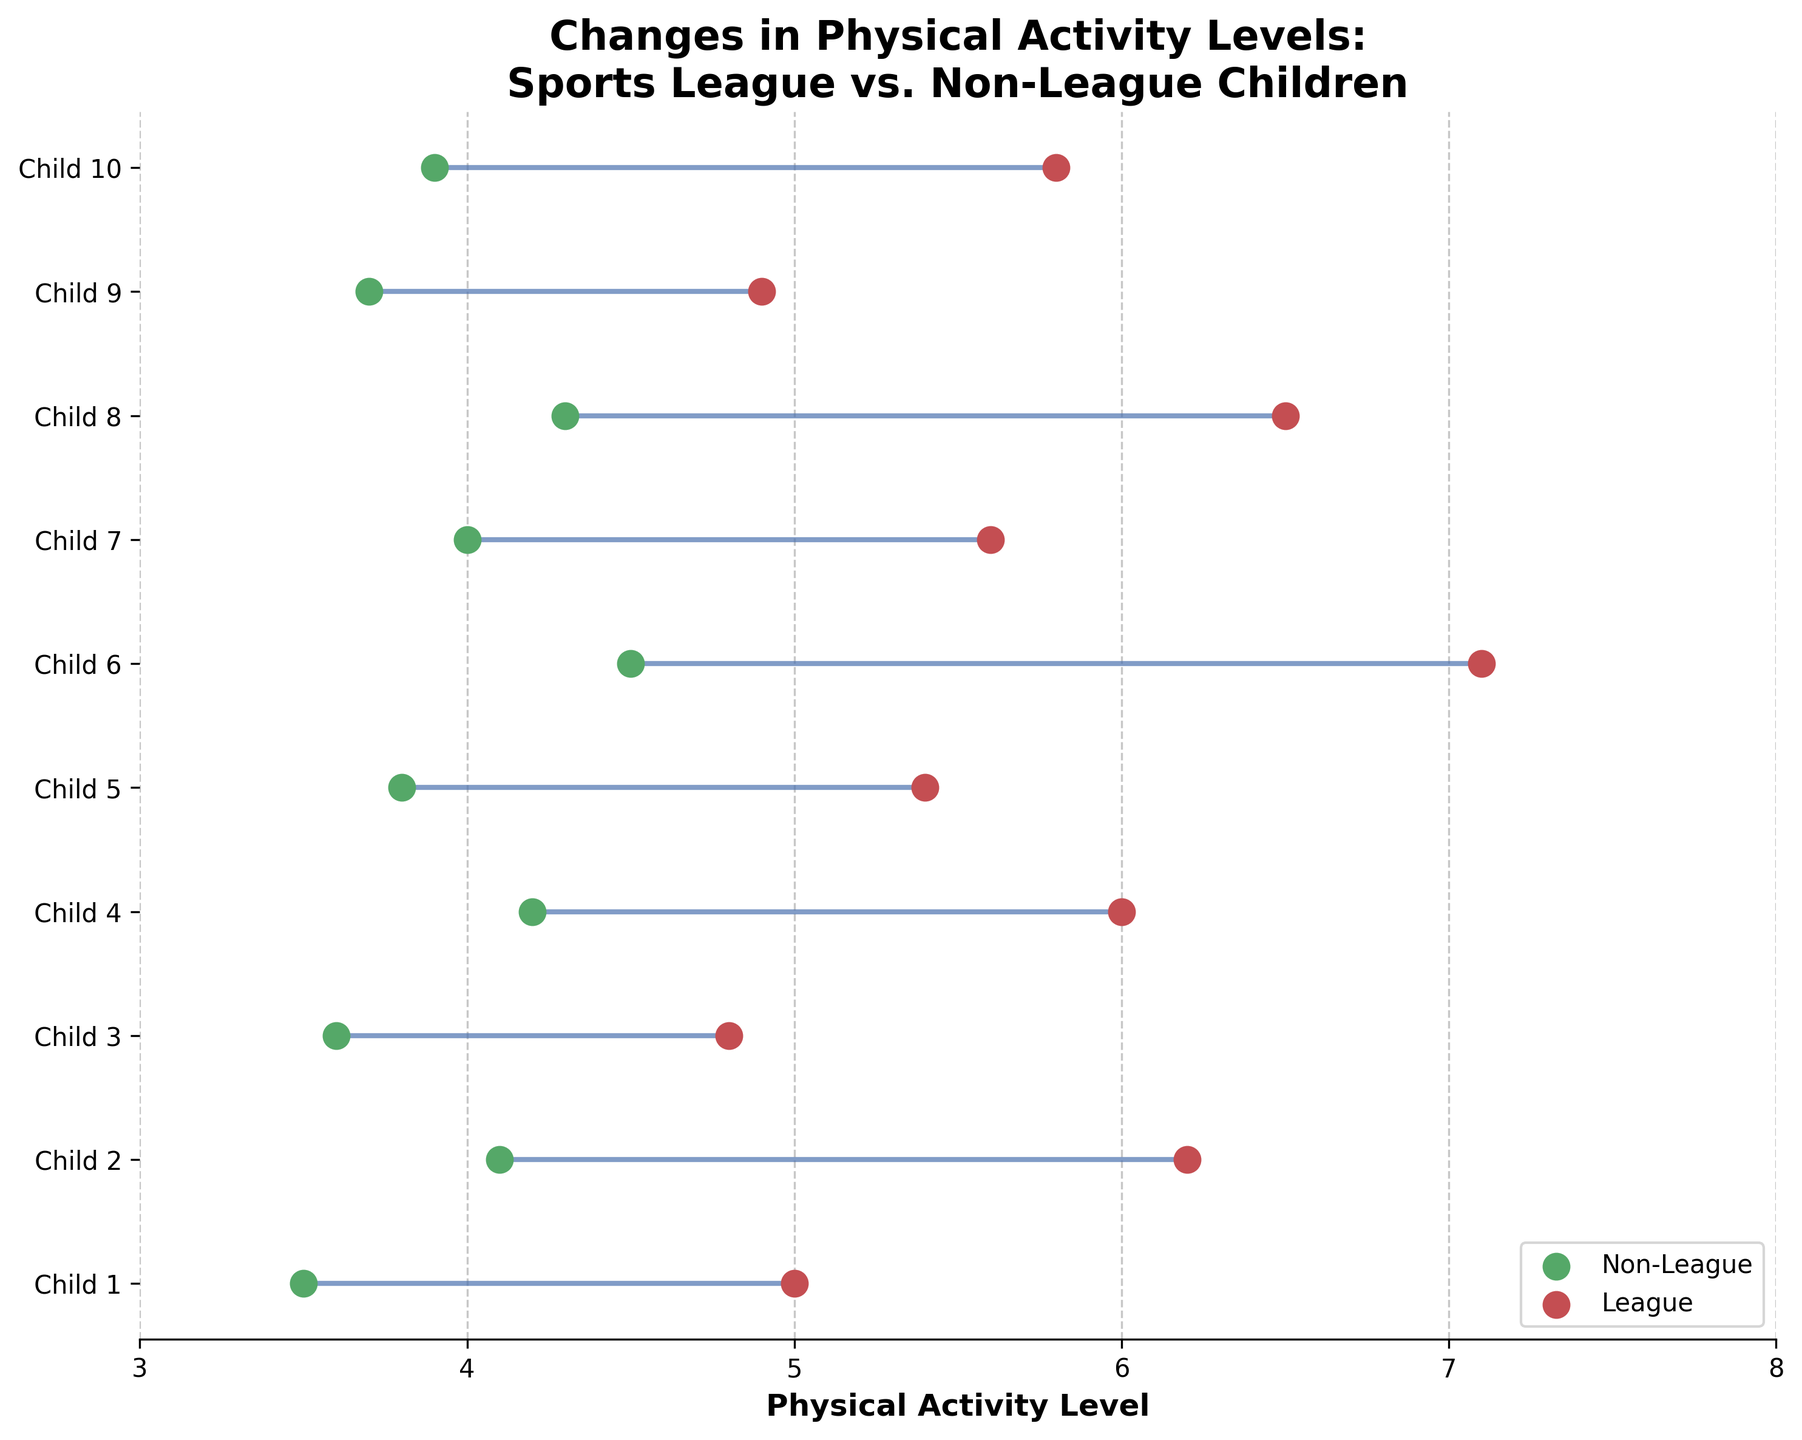What's the title of the plot? The title of the plot is displayed at the top of the figure and is emphasized in bold text.
Answer: Changes in Physical Activity Levels: Sports League vs. Non-League Children How many children are represented in the data? The y-axis labels are associated with each child, counting from Child 1 to Child 10.
Answer: 10 Which child shows the smallest increase in physical activity levels from Non-League to League? The child with the smallest vertical length between the dots representing Non-League and League shows the smallest increase, which is Child 3.
Answer: Child 3 What's the average physical activity level for children who didn't join sports leagues? To find the average activity level for Non-League children, sum all the Non-League values and divide by the number of children: (3.5 + 4.1 + 3.6 + 4.2 + 3.8 + 4.5 + 4.0 + 4.3 + 3.7 + 3.9)/10.
Answer: 3.96 Which two children show the highest difference in their physical activity levels between League and Non-League groups? Identify children with the largest vertical gaps, Child 6 and Child 8 show the largest increase when comparing positions in League and Non-League groups.
Answer: Child 6 and Child 8 Is the range of physical activity levels larger for the League or Non-League group? To determine the range, subtract the smallest value from the largest value in each group. For League: 7.1 - 4.8 = 2.3, for Non-League: 4.5 - 3.5 = 1.0.
Answer: League Which color is used to represent children in the League group? Colors are typically annotated in the scatter plot. Red dots are used in the figure to represent the League group.
Answer: Red What's the difference in physical activity levels for Child 1 between the League and Non-League groups? Identify the activity levels of Child 1 in both groups from the y-axis: 5.0 (League) - 3.5 (Non-League) = 1.5.
Answer: 1.5 How many children in the League group have physical activity levels greater than 5.5? Count the children in the League group who have physical activity levels above 5.5 by examining the scatter plot above the 5.5 level. These are Child 2, Child 6, and Child 8, totaling three children.
Answer: 3 